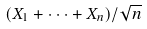<formula> <loc_0><loc_0><loc_500><loc_500>( X _ { 1 } + \cdot \cdot \cdot + X _ { n } ) / \sqrt { n }</formula> 